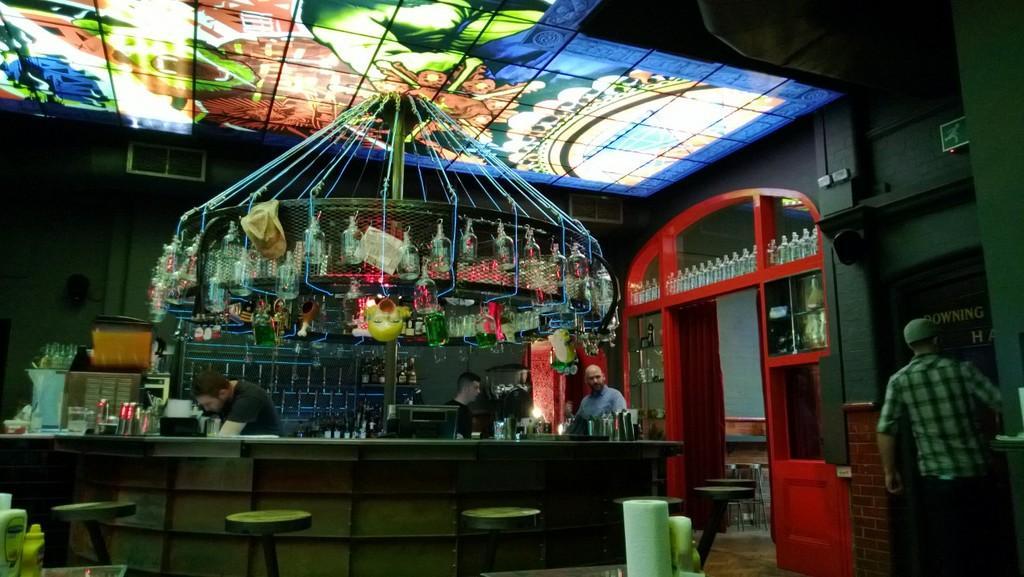Could you give a brief overview of what you see in this image? It looks like a bar, in the middle a man is standing, there are wine bottles in the racks. On the right side a man is walking. 